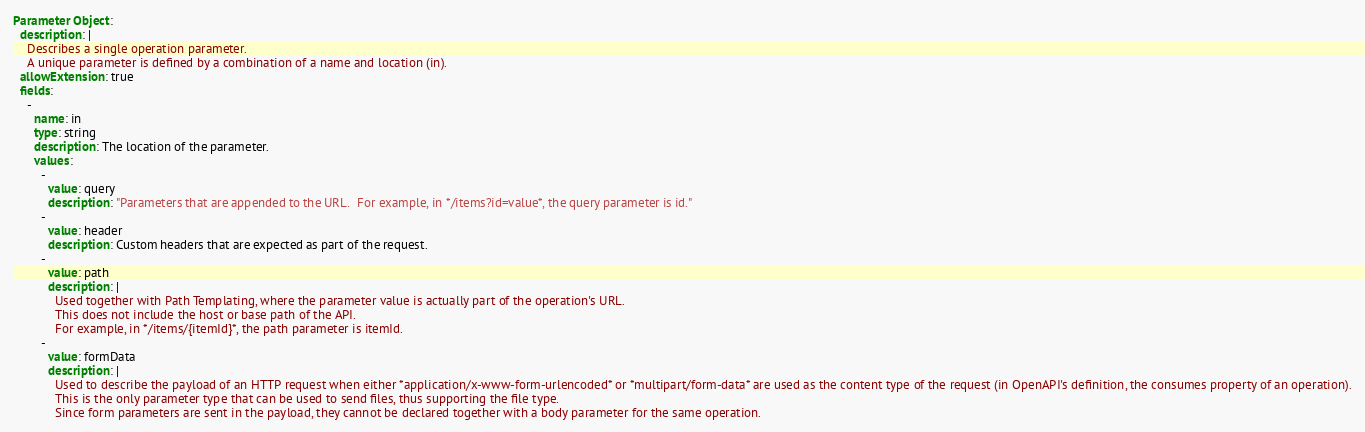<code> <loc_0><loc_0><loc_500><loc_500><_YAML_>Parameter Object:
  description: |
    Describes a single operation parameter.
    A unique parameter is defined by a combination of a name and location (in).
  allowExtension: true
  fields:
    -
      name: in
      type: string
      description: The location of the parameter.
      values:
        -
          value: query
          description: "Parameters that are appended to the URL.  For example, in */items?id=value*, the query parameter is id."
        -
          value: header
          description: Custom headers that are expected as part of the request.
        -
          value: path
          description: |
            Used together with Path Templating, where the parameter value is actually part of the operation's URL.
            This does not include the host or base path of the API.
            For example, in */items/{itemId}*, the path parameter is itemId.
        -
          value: formData
          description: |
            Used to describe the payload of an HTTP request when either *application/x-www-form-urlencoded* or *multipart/form-data* are used as the content type of the request (in OpenAPI's definition, the consumes property of an operation).
            This is the only parameter type that can be used to send files, thus supporting the file type.
            Since form parameters are sent in the payload, they cannot be declared together with a body parameter for the same operation.</code> 